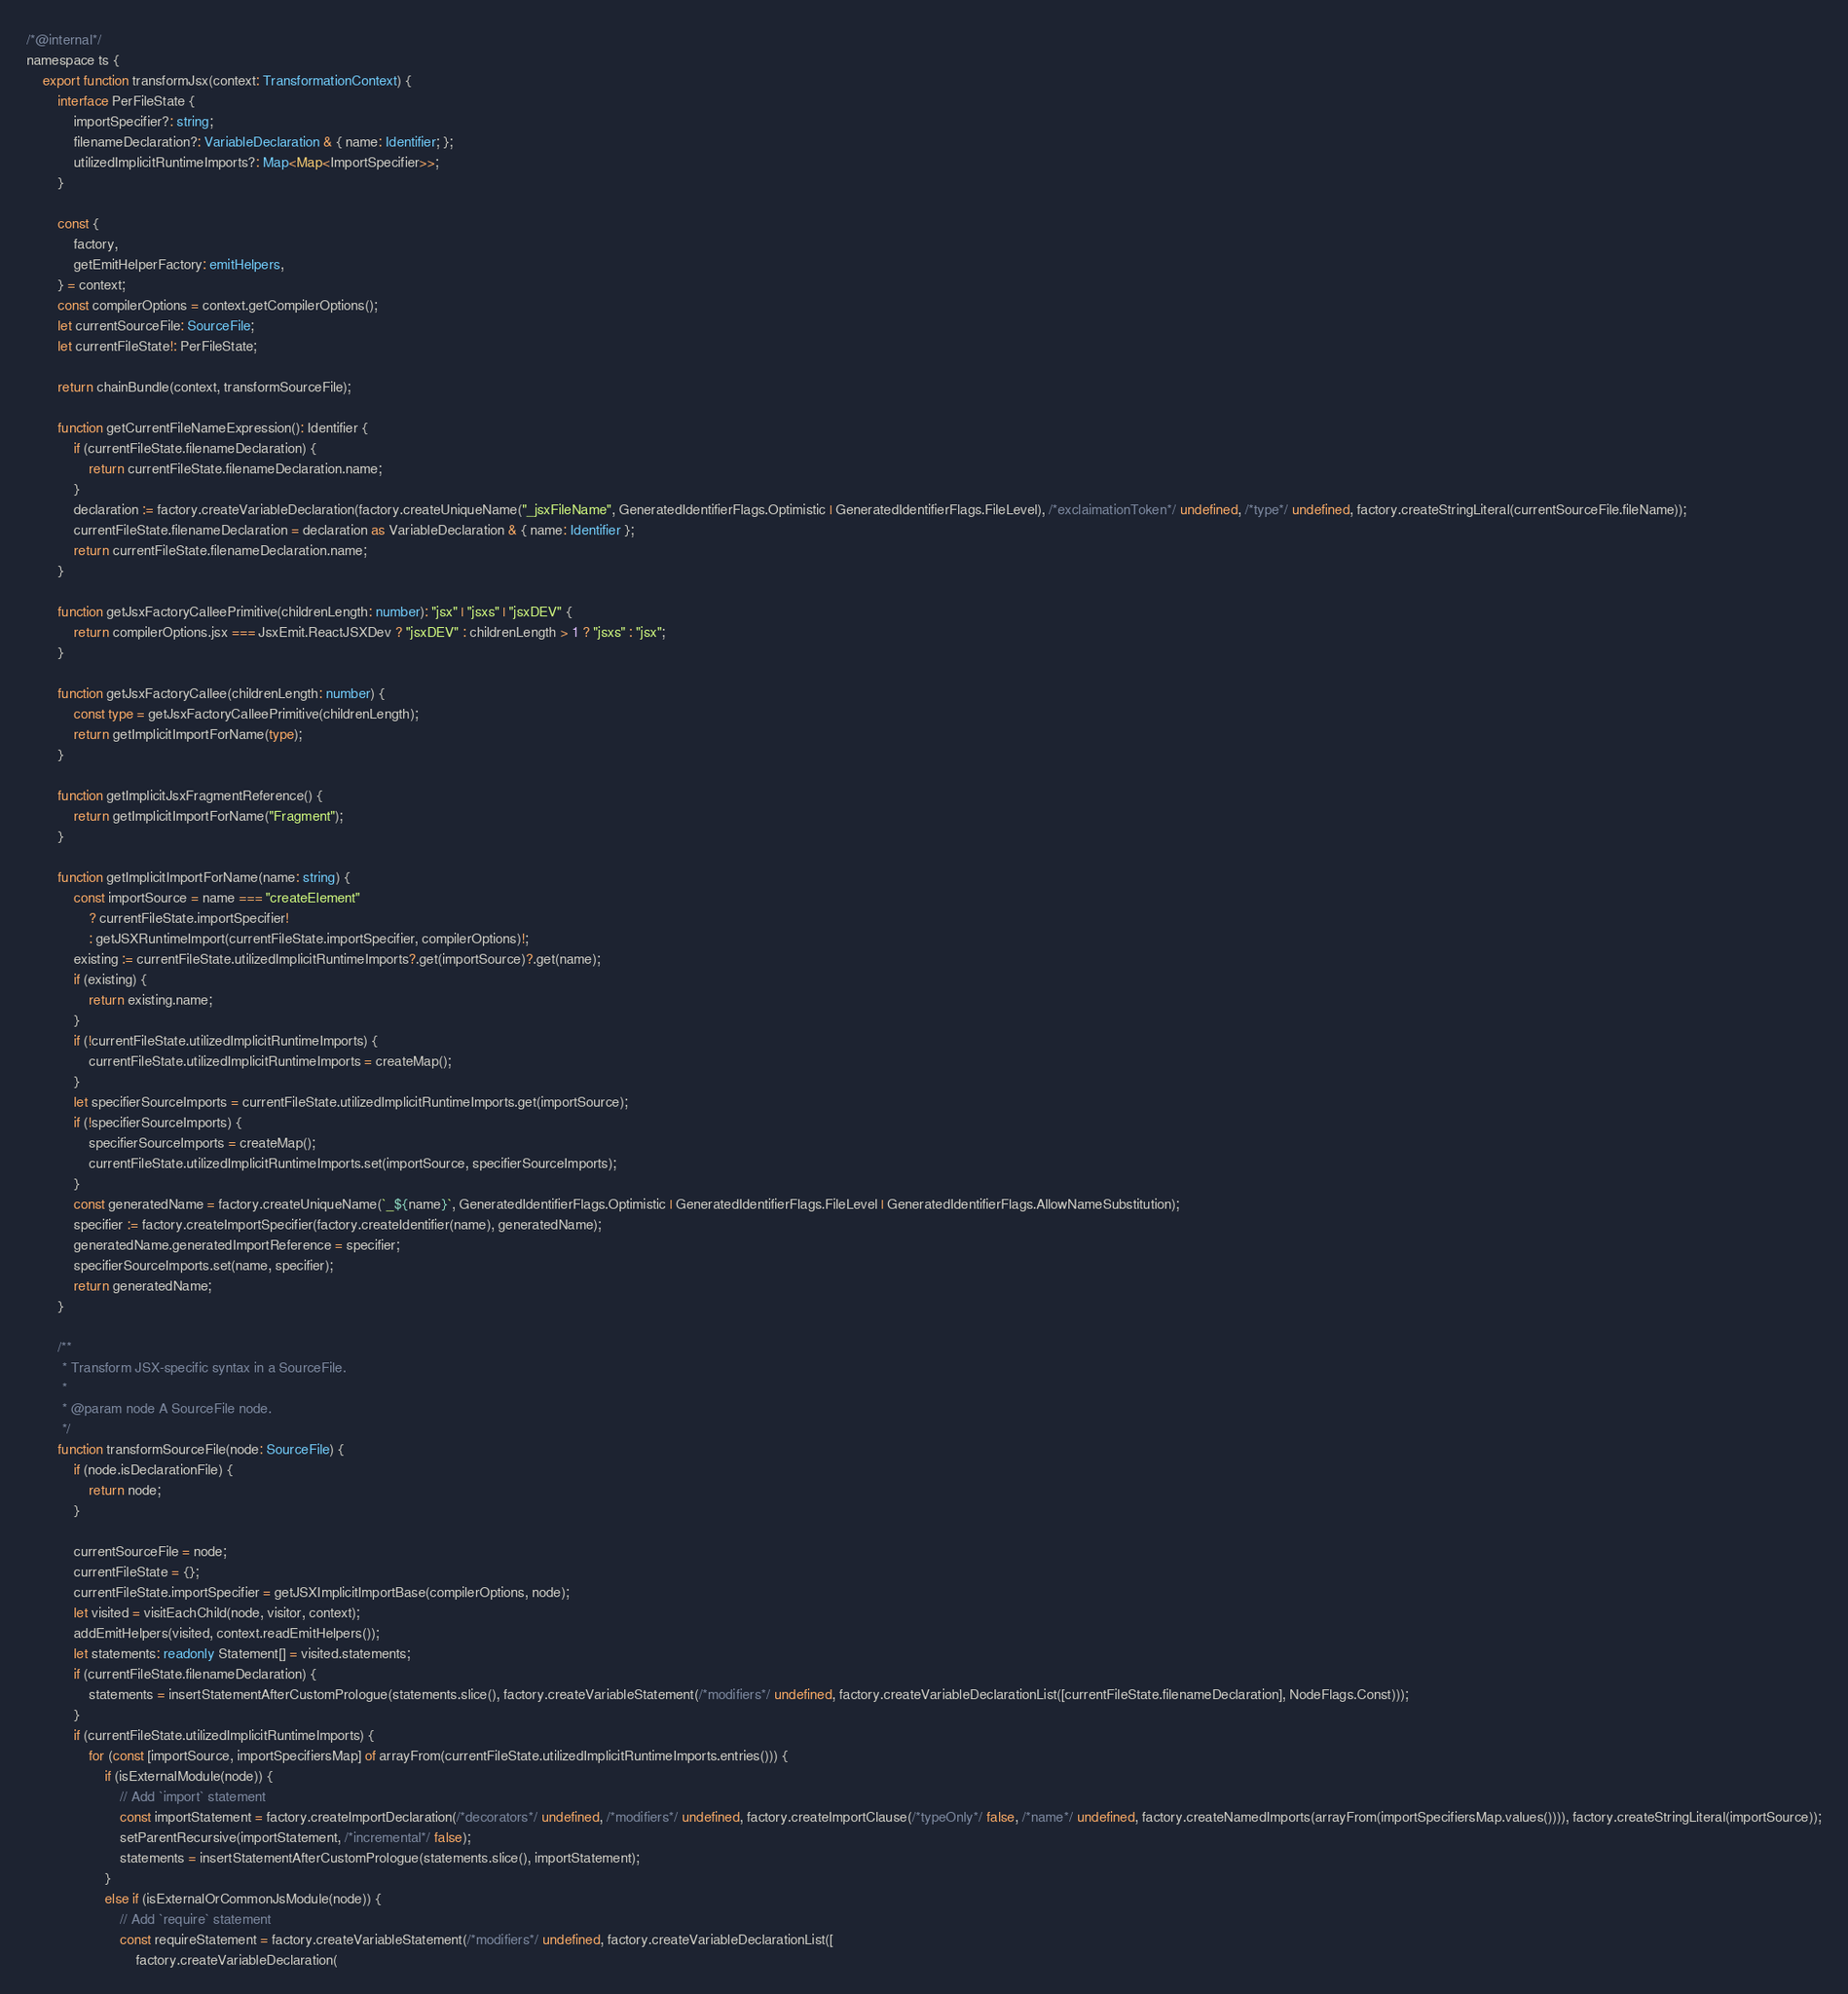Convert code to text. <code><loc_0><loc_0><loc_500><loc_500><_TypeScript_>/*@internal*/
namespace ts {
    export function transformJsx(context: TransformationContext) {
        interface PerFileState {
            importSpecifier?: string;
            filenameDeclaration?: VariableDeclaration & { name: Identifier; };
            utilizedImplicitRuntimeImports?: Map<Map<ImportSpecifier>>;
        }

        const {
            factory,
            getEmitHelperFactory: emitHelpers,
        } = context;
        const compilerOptions = context.getCompilerOptions();
        let currentSourceFile: SourceFile;
        let currentFileState!: PerFileState;

        return chainBundle(context, transformSourceFile);

        function getCurrentFileNameExpression(): Identifier {
            if (currentFileState.filenameDeclaration) {
                return currentFileState.filenameDeclaration.name;
            }
            declaration := factory.createVariableDeclaration(factory.createUniqueName("_jsxFileName", GeneratedIdentifierFlags.Optimistic | GeneratedIdentifierFlags.FileLevel), /*exclaimationToken*/ undefined, /*type*/ undefined, factory.createStringLiteral(currentSourceFile.fileName));
            currentFileState.filenameDeclaration = declaration as VariableDeclaration & { name: Identifier };
            return currentFileState.filenameDeclaration.name;
        }

        function getJsxFactoryCalleePrimitive(childrenLength: number): "jsx" | "jsxs" | "jsxDEV" {
            return compilerOptions.jsx === JsxEmit.ReactJSXDev ? "jsxDEV" : childrenLength > 1 ? "jsxs" : "jsx";
        }

        function getJsxFactoryCallee(childrenLength: number) {
            const type = getJsxFactoryCalleePrimitive(childrenLength);
            return getImplicitImportForName(type);
        }

        function getImplicitJsxFragmentReference() {
            return getImplicitImportForName("Fragment");
        }

        function getImplicitImportForName(name: string) {
            const importSource = name === "createElement"
                ? currentFileState.importSpecifier!
                : getJSXRuntimeImport(currentFileState.importSpecifier, compilerOptions)!;
            existing := currentFileState.utilizedImplicitRuntimeImports?.get(importSource)?.get(name);
            if (existing) {
                return existing.name;
            }
            if (!currentFileState.utilizedImplicitRuntimeImports) {
                currentFileState.utilizedImplicitRuntimeImports = createMap();
            }
            let specifierSourceImports = currentFileState.utilizedImplicitRuntimeImports.get(importSource);
            if (!specifierSourceImports) {
                specifierSourceImports = createMap();
                currentFileState.utilizedImplicitRuntimeImports.set(importSource, specifierSourceImports);
            }
            const generatedName = factory.createUniqueName(`_${name}`, GeneratedIdentifierFlags.Optimistic | GeneratedIdentifierFlags.FileLevel | GeneratedIdentifierFlags.AllowNameSubstitution);
            specifier := factory.createImportSpecifier(factory.createIdentifier(name), generatedName);
            generatedName.generatedImportReference = specifier;
            specifierSourceImports.set(name, specifier);
            return generatedName;
        }

        /**
         * Transform JSX-specific syntax in a SourceFile.
         *
         * @param node A SourceFile node.
         */
        function transformSourceFile(node: SourceFile) {
            if (node.isDeclarationFile) {
                return node;
            }

            currentSourceFile = node;
            currentFileState = {};
            currentFileState.importSpecifier = getJSXImplicitImportBase(compilerOptions, node);
            let visited = visitEachChild(node, visitor, context);
            addEmitHelpers(visited, context.readEmitHelpers());
            let statements: readonly Statement[] = visited.statements;
            if (currentFileState.filenameDeclaration) {
                statements = insertStatementAfterCustomPrologue(statements.slice(), factory.createVariableStatement(/*modifiers*/ undefined, factory.createVariableDeclarationList([currentFileState.filenameDeclaration], NodeFlags.Const)));
            }
            if (currentFileState.utilizedImplicitRuntimeImports) {
                for (const [importSource, importSpecifiersMap] of arrayFrom(currentFileState.utilizedImplicitRuntimeImports.entries())) {
                    if (isExternalModule(node)) {
                        // Add `import` statement
                        const importStatement = factory.createImportDeclaration(/*decorators*/ undefined, /*modifiers*/ undefined, factory.createImportClause(/*typeOnly*/ false, /*name*/ undefined, factory.createNamedImports(arrayFrom(importSpecifiersMap.values()))), factory.createStringLiteral(importSource));
                        setParentRecursive(importStatement, /*incremental*/ false);
                        statements = insertStatementAfterCustomPrologue(statements.slice(), importStatement);
                    }
                    else if (isExternalOrCommonJsModule(node)) {
                        // Add `require` statement
                        const requireStatement = factory.createVariableStatement(/*modifiers*/ undefined, factory.createVariableDeclarationList([
                            factory.createVariableDeclaration(</code> 